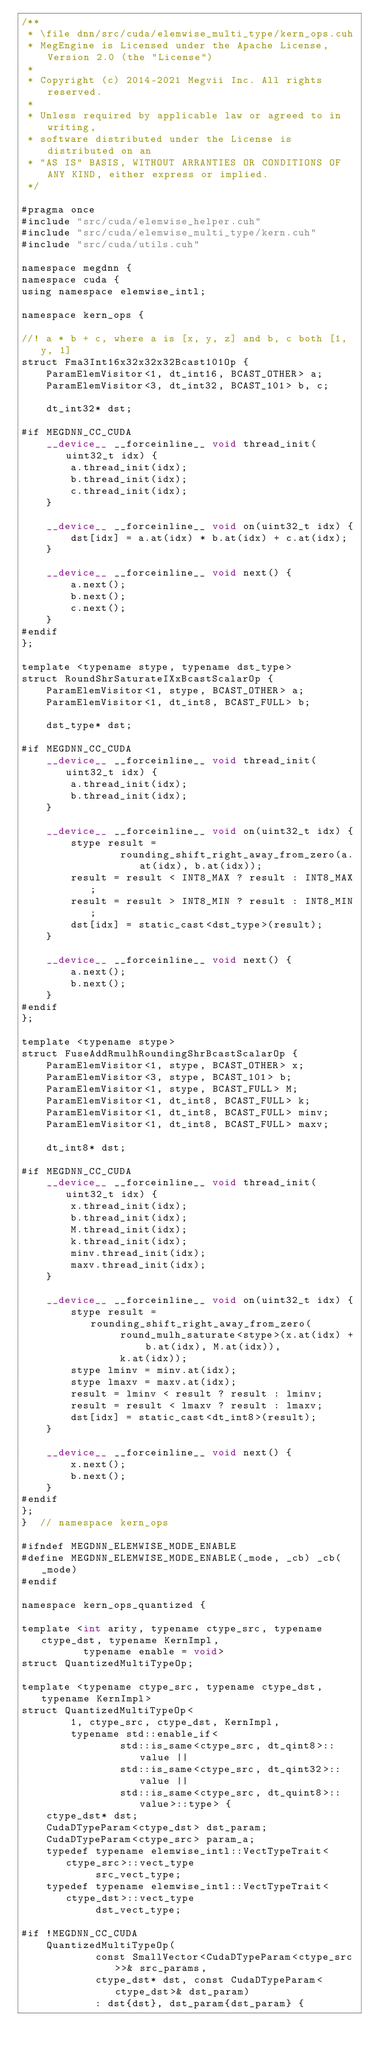Convert code to text. <code><loc_0><loc_0><loc_500><loc_500><_Cuda_>/**
 * \file dnn/src/cuda/elemwise_multi_type/kern_ops.cuh
 * MegEngine is Licensed under the Apache License, Version 2.0 (the "License")
 *
 * Copyright (c) 2014-2021 Megvii Inc. All rights reserved.
 *
 * Unless required by applicable law or agreed to in writing,
 * software distributed under the License is distributed on an
 * "AS IS" BASIS, WITHOUT ARRANTIES OR CONDITIONS OF ANY KIND, either express or implied.
 */

#pragma once
#include "src/cuda/elemwise_helper.cuh"
#include "src/cuda/elemwise_multi_type/kern.cuh"
#include "src/cuda/utils.cuh"

namespace megdnn {
namespace cuda {
using namespace elemwise_intl;

namespace kern_ops {

//! a * b + c, where a is [x, y, z] and b, c both [1, y, 1]
struct Fma3Int16x32x32x32Bcast101Op {
    ParamElemVisitor<1, dt_int16, BCAST_OTHER> a;
    ParamElemVisitor<3, dt_int32, BCAST_101> b, c;

    dt_int32* dst;

#if MEGDNN_CC_CUDA
    __device__ __forceinline__ void thread_init(uint32_t idx) {
        a.thread_init(idx);
        b.thread_init(idx);
        c.thread_init(idx);
    }

    __device__ __forceinline__ void on(uint32_t idx) {
        dst[idx] = a.at(idx) * b.at(idx) + c.at(idx);
    }

    __device__ __forceinline__ void next() {
        a.next();
        b.next();
        c.next();
    }
#endif
};

template <typename stype, typename dst_type>
struct RoundShrSaturateIXxBcastScalarOp {
    ParamElemVisitor<1, stype, BCAST_OTHER> a;
    ParamElemVisitor<1, dt_int8, BCAST_FULL> b;

    dst_type* dst;

#if MEGDNN_CC_CUDA
    __device__ __forceinline__ void thread_init(uint32_t idx) {
        a.thread_init(idx);
        b.thread_init(idx);
    }

    __device__ __forceinline__ void on(uint32_t idx) {
        stype result =
                rounding_shift_right_away_from_zero(a.at(idx), b.at(idx));
        result = result < INT8_MAX ? result : INT8_MAX;
        result = result > INT8_MIN ? result : INT8_MIN;
        dst[idx] = static_cast<dst_type>(result);
    }

    __device__ __forceinline__ void next() {
        a.next();
        b.next();
    }
#endif
};

template <typename stype>
struct FuseAddRmulhRoundingShrBcastScalarOp {
    ParamElemVisitor<1, stype, BCAST_OTHER> x;
    ParamElemVisitor<3, stype, BCAST_101> b;
    ParamElemVisitor<1, stype, BCAST_FULL> M;
    ParamElemVisitor<1, dt_int8, BCAST_FULL> k;
    ParamElemVisitor<1, dt_int8, BCAST_FULL> minv;
    ParamElemVisitor<1, dt_int8, BCAST_FULL> maxv;

    dt_int8* dst;

#if MEGDNN_CC_CUDA
    __device__ __forceinline__ void thread_init(uint32_t idx) {
        x.thread_init(idx);
        b.thread_init(idx);
        M.thread_init(idx);
        k.thread_init(idx);
        minv.thread_init(idx);
        maxv.thread_init(idx);
    }

    __device__ __forceinline__ void on(uint32_t idx) {
        stype result = rounding_shift_right_away_from_zero(
                round_mulh_saturate<stype>(x.at(idx) + b.at(idx), M.at(idx)),
                k.at(idx));
        stype lminv = minv.at(idx);
        stype lmaxv = maxv.at(idx);
        result = lminv < result ? result : lminv;
        result = result < lmaxv ? result : lmaxv;
        dst[idx] = static_cast<dt_int8>(result);
    }

    __device__ __forceinline__ void next() {
        x.next();
        b.next();
    }
#endif
};
}  // namespace kern_ops

#ifndef MEGDNN_ELEMWISE_MODE_ENABLE
#define MEGDNN_ELEMWISE_MODE_ENABLE(_mode, _cb) _cb(_mode)
#endif

namespace kern_ops_quantized {

template <int arity, typename ctype_src, typename ctype_dst, typename KernImpl,
          typename enable = void>
struct QuantizedMultiTypeOp;

template <typename ctype_src, typename ctype_dst, typename KernImpl>
struct QuantizedMultiTypeOp<
        1, ctype_src, ctype_dst, KernImpl,
        typename std::enable_if<
                std::is_same<ctype_src, dt_qint8>::value ||
                std::is_same<ctype_src, dt_qint32>::value ||
                std::is_same<ctype_src, dt_quint8>::value>::type> {
    ctype_dst* dst;
    CudaDTypeParam<ctype_dst> dst_param;
    CudaDTypeParam<ctype_src> param_a;
    typedef typename elemwise_intl::VectTypeTrait<ctype_src>::vect_type
            src_vect_type;
    typedef typename elemwise_intl::VectTypeTrait<ctype_dst>::vect_type
            dst_vect_type;

#if !MEGDNN_CC_CUDA
    QuantizedMultiTypeOp(
            const SmallVector<CudaDTypeParam<ctype_src>>& src_params,
            ctype_dst* dst, const CudaDTypeParam<ctype_dst>& dst_param)
            : dst{dst}, dst_param{dst_param} {</code> 